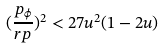Convert formula to latex. <formula><loc_0><loc_0><loc_500><loc_500>( \frac { p _ { \phi } } { r p } ) ^ { 2 } < 2 7 u ^ { 2 } ( 1 - 2 u )</formula> 